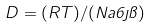Convert formula to latex. <formula><loc_0><loc_0><loc_500><loc_500>D = ( R T ) / ( N a 6 \eta \pi )</formula> 